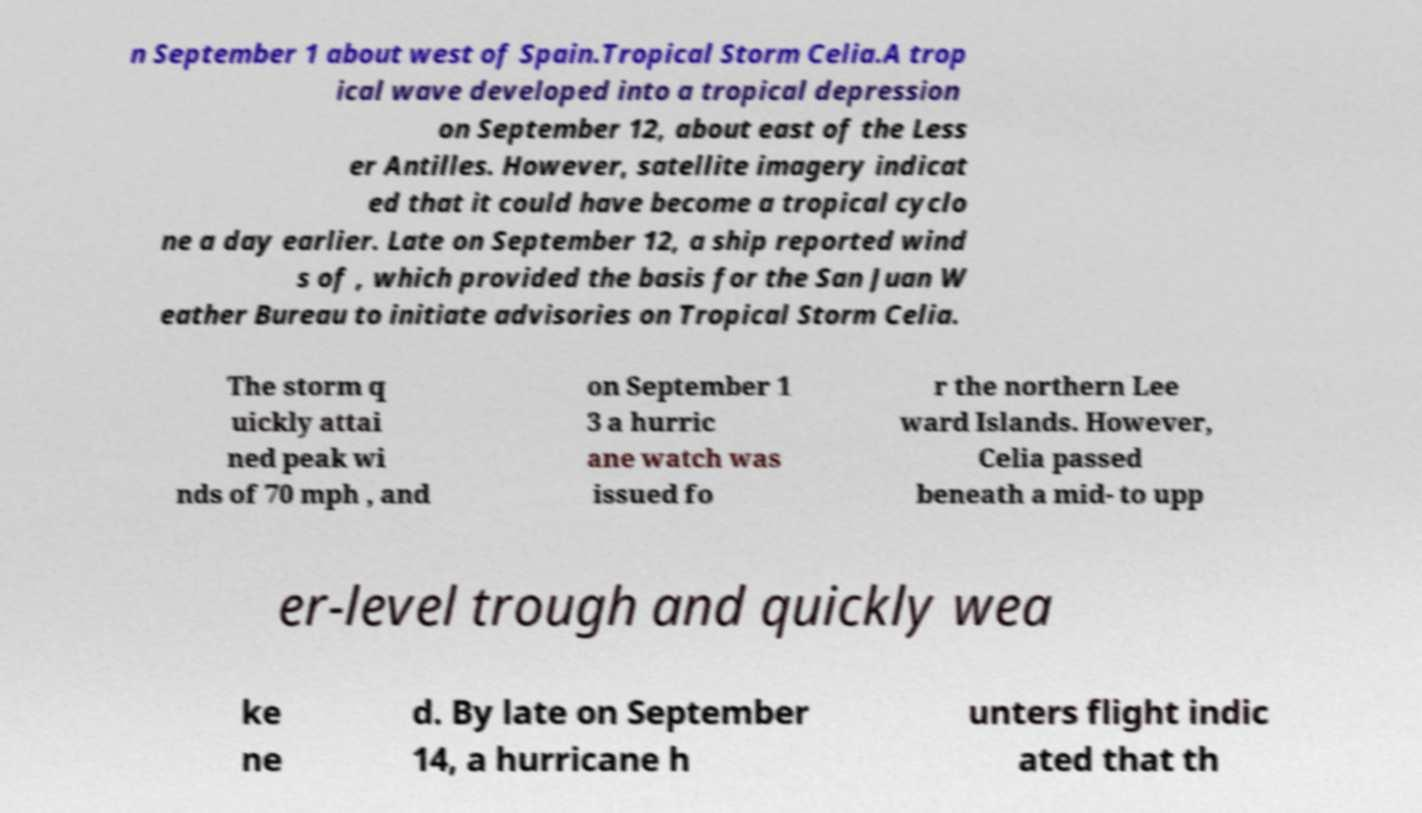Can you read and provide the text displayed in the image?This photo seems to have some interesting text. Can you extract and type it out for me? n September 1 about west of Spain.Tropical Storm Celia.A trop ical wave developed into a tropical depression on September 12, about east of the Less er Antilles. However, satellite imagery indicat ed that it could have become a tropical cyclo ne a day earlier. Late on September 12, a ship reported wind s of , which provided the basis for the San Juan W eather Bureau to initiate advisories on Tropical Storm Celia. The storm q uickly attai ned peak wi nds of 70 mph , and on September 1 3 a hurric ane watch was issued fo r the northern Lee ward Islands. However, Celia passed beneath a mid- to upp er-level trough and quickly wea ke ne d. By late on September 14, a hurricane h unters flight indic ated that th 